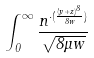<formula> <loc_0><loc_0><loc_500><loc_500>\int _ { 0 } ^ { \infty } \frac { n ^ { \cdot ( \frac { ( y + z ) ^ { 8 } } { 8 w } ) } } { \sqrt { 8 \mu w } }</formula> 